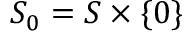Convert formula to latex. <formula><loc_0><loc_0><loc_500><loc_500>S _ { 0 } = S \times \{ 0 \}</formula> 